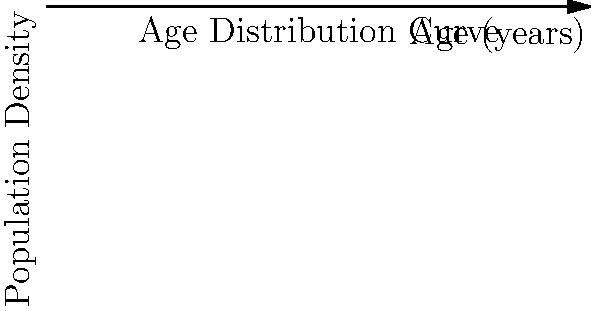Given the age distribution curve $f(x) = 0.05e^{-0.05x}$, where $x$ represents age in years and $f(x)$ represents the population density at age $x$, calculate the total population between the ages of 20 and 60 years old. Round your answer to the nearest whole number. To solve this problem, we need to integrate the age distribution function over the given interval. Here's the step-by-step solution:

1) The total population between ages 20 and 60 is given by the definite integral:

   $$P = \int_{20}^{60} 0.05e^{-0.05x} dx$$

2) To evaluate this integral, we can use the substitution method or recall the antiderivative of $e^{ax}$:

   $$\int e^{ax} dx = \frac{1}{a}e^{ax} + C$$

3) Applying this to our problem:

   $$P = -e^{-0.05x}|_{20}^{60}$$

4) Evaluating the definite integral:

   $$P = -e^{-0.05(60)} - (-e^{-0.05(20)})$$
   $$P = -e^{-3} + e^{-1}$$

5) Calculate the values:

   $$P = -0.0497871 + 0.3678794$$
   $$P = 0.3180923$$

6) This represents the fraction of the total population between ages 20 and 60.

7) To get the actual population count, we need to multiply by the total population. Assuming the total population is 1 (since the integral of the density function from 0 to infinity equals 1), our result is already in the correct form.

8) Rounding to the nearest whole number:

   $$P \approx 0.3180923 \times 100\% \approx 32\%$$
Answer: 32% of the total population 